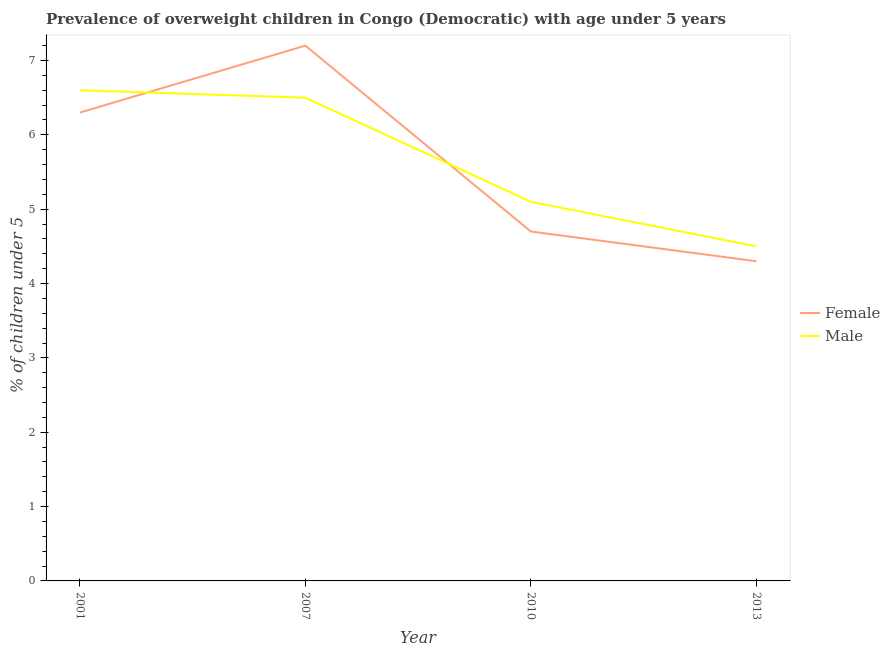What is the percentage of obese female children in 2013?
Your response must be concise. 4.3. Across all years, what is the maximum percentage of obese female children?
Your response must be concise. 7.2. What is the total percentage of obese female children in the graph?
Make the answer very short. 22.5. What is the difference between the percentage of obese female children in 2010 and that in 2013?
Ensure brevity in your answer.  0.4. What is the difference between the percentage of obese female children in 2001 and the percentage of obese male children in 2007?
Provide a short and direct response. -0.2. What is the average percentage of obese male children per year?
Offer a terse response. 5.67. In the year 2001, what is the difference between the percentage of obese female children and percentage of obese male children?
Provide a short and direct response. -0.3. What is the ratio of the percentage of obese female children in 2007 to that in 2013?
Offer a very short reply. 1.67. Is the percentage of obese female children in 2010 less than that in 2013?
Keep it short and to the point. No. What is the difference between the highest and the second highest percentage of obese female children?
Make the answer very short. 0.9. What is the difference between the highest and the lowest percentage of obese male children?
Offer a very short reply. 2.1. In how many years, is the percentage of obese male children greater than the average percentage of obese male children taken over all years?
Your answer should be very brief. 2. Is the percentage of obese male children strictly greater than the percentage of obese female children over the years?
Your response must be concise. No. Is the percentage of obese male children strictly less than the percentage of obese female children over the years?
Offer a very short reply. No. How many years are there in the graph?
Provide a succinct answer. 4. What is the difference between two consecutive major ticks on the Y-axis?
Ensure brevity in your answer.  1. Does the graph contain any zero values?
Keep it short and to the point. No. Does the graph contain grids?
Offer a terse response. No. How many legend labels are there?
Your answer should be compact. 2. What is the title of the graph?
Ensure brevity in your answer.  Prevalence of overweight children in Congo (Democratic) with age under 5 years. Does "By country of asylum" appear as one of the legend labels in the graph?
Give a very brief answer. No. What is the label or title of the X-axis?
Provide a succinct answer. Year. What is the label or title of the Y-axis?
Give a very brief answer.  % of children under 5. What is the  % of children under 5 in Female in 2001?
Ensure brevity in your answer.  6.3. What is the  % of children under 5 in Male in 2001?
Provide a short and direct response. 6.6. What is the  % of children under 5 of Female in 2007?
Offer a very short reply. 7.2. What is the  % of children under 5 of Female in 2010?
Offer a very short reply. 4.7. What is the  % of children under 5 of Male in 2010?
Provide a short and direct response. 5.1. What is the  % of children under 5 in Female in 2013?
Keep it short and to the point. 4.3. Across all years, what is the maximum  % of children under 5 in Female?
Provide a short and direct response. 7.2. Across all years, what is the maximum  % of children under 5 of Male?
Ensure brevity in your answer.  6.6. Across all years, what is the minimum  % of children under 5 of Female?
Your answer should be very brief. 4.3. Across all years, what is the minimum  % of children under 5 in Male?
Give a very brief answer. 4.5. What is the total  % of children under 5 of Male in the graph?
Your answer should be very brief. 22.7. What is the difference between the  % of children under 5 of Female in 2001 and that in 2007?
Your answer should be very brief. -0.9. What is the difference between the  % of children under 5 of Male in 2001 and that in 2007?
Your answer should be very brief. 0.1. What is the difference between the  % of children under 5 of Female in 2001 and that in 2010?
Give a very brief answer. 1.6. What is the difference between the  % of children under 5 in Female in 2001 and that in 2013?
Offer a very short reply. 2. What is the difference between the  % of children under 5 of Female in 2007 and that in 2010?
Keep it short and to the point. 2.5. What is the difference between the  % of children under 5 of Female in 2007 and that in 2013?
Provide a succinct answer. 2.9. What is the difference between the  % of children under 5 of Female in 2001 and the  % of children under 5 of Male in 2007?
Give a very brief answer. -0.2. What is the difference between the  % of children under 5 of Female in 2001 and the  % of children under 5 of Male in 2013?
Offer a terse response. 1.8. What is the difference between the  % of children under 5 in Female in 2007 and the  % of children under 5 in Male in 2010?
Give a very brief answer. 2.1. What is the difference between the  % of children under 5 in Female in 2007 and the  % of children under 5 in Male in 2013?
Ensure brevity in your answer.  2.7. What is the difference between the  % of children under 5 of Female in 2010 and the  % of children under 5 of Male in 2013?
Provide a short and direct response. 0.2. What is the average  % of children under 5 of Female per year?
Your response must be concise. 5.62. What is the average  % of children under 5 in Male per year?
Provide a succinct answer. 5.67. In the year 2001, what is the difference between the  % of children under 5 in Female and  % of children under 5 in Male?
Provide a short and direct response. -0.3. In the year 2010, what is the difference between the  % of children under 5 in Female and  % of children under 5 in Male?
Your response must be concise. -0.4. In the year 2013, what is the difference between the  % of children under 5 of Female and  % of children under 5 of Male?
Provide a succinct answer. -0.2. What is the ratio of the  % of children under 5 of Male in 2001 to that in 2007?
Offer a terse response. 1.02. What is the ratio of the  % of children under 5 in Female in 2001 to that in 2010?
Keep it short and to the point. 1.34. What is the ratio of the  % of children under 5 in Male in 2001 to that in 2010?
Provide a short and direct response. 1.29. What is the ratio of the  % of children under 5 of Female in 2001 to that in 2013?
Offer a terse response. 1.47. What is the ratio of the  % of children under 5 in Male in 2001 to that in 2013?
Keep it short and to the point. 1.47. What is the ratio of the  % of children under 5 in Female in 2007 to that in 2010?
Your response must be concise. 1.53. What is the ratio of the  % of children under 5 in Male in 2007 to that in 2010?
Your answer should be very brief. 1.27. What is the ratio of the  % of children under 5 of Female in 2007 to that in 2013?
Offer a terse response. 1.67. What is the ratio of the  % of children under 5 of Male in 2007 to that in 2013?
Give a very brief answer. 1.44. What is the ratio of the  % of children under 5 of Female in 2010 to that in 2013?
Offer a terse response. 1.09. What is the ratio of the  % of children under 5 of Male in 2010 to that in 2013?
Give a very brief answer. 1.13. What is the difference between the highest and the lowest  % of children under 5 in Female?
Ensure brevity in your answer.  2.9. What is the difference between the highest and the lowest  % of children under 5 of Male?
Provide a succinct answer. 2.1. 